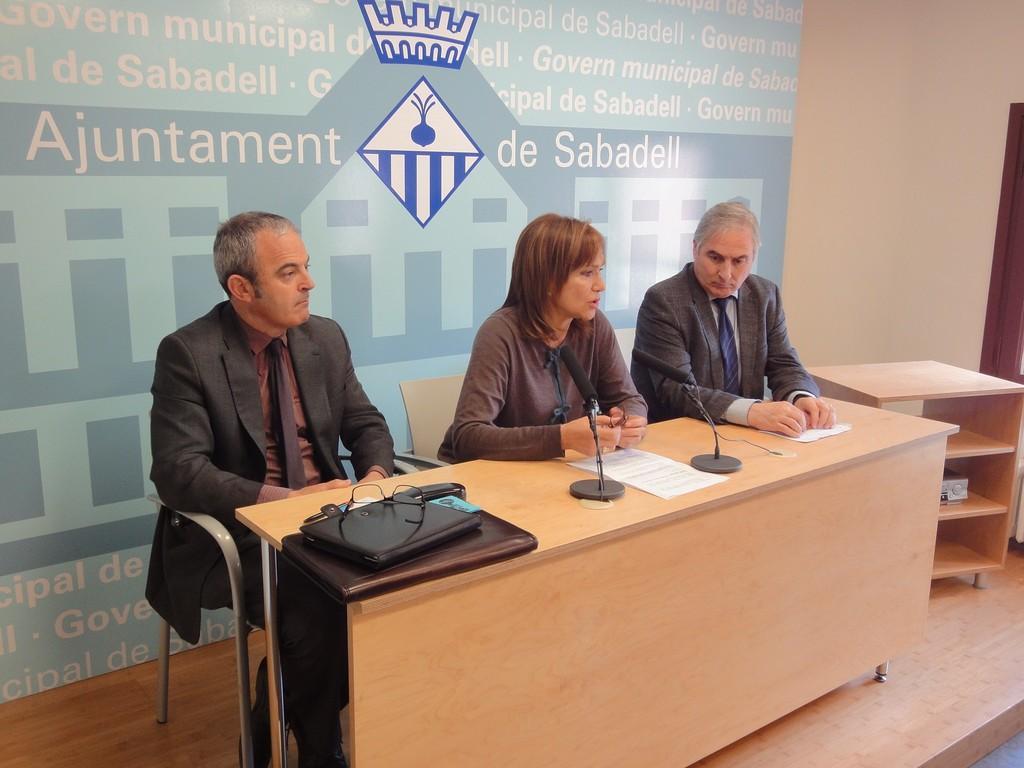Can you describe this image briefly? in the picture there are two man and one woman are sitting on chair with the table in front of them,the woman is talking in the micro phone on the table there are many items. 